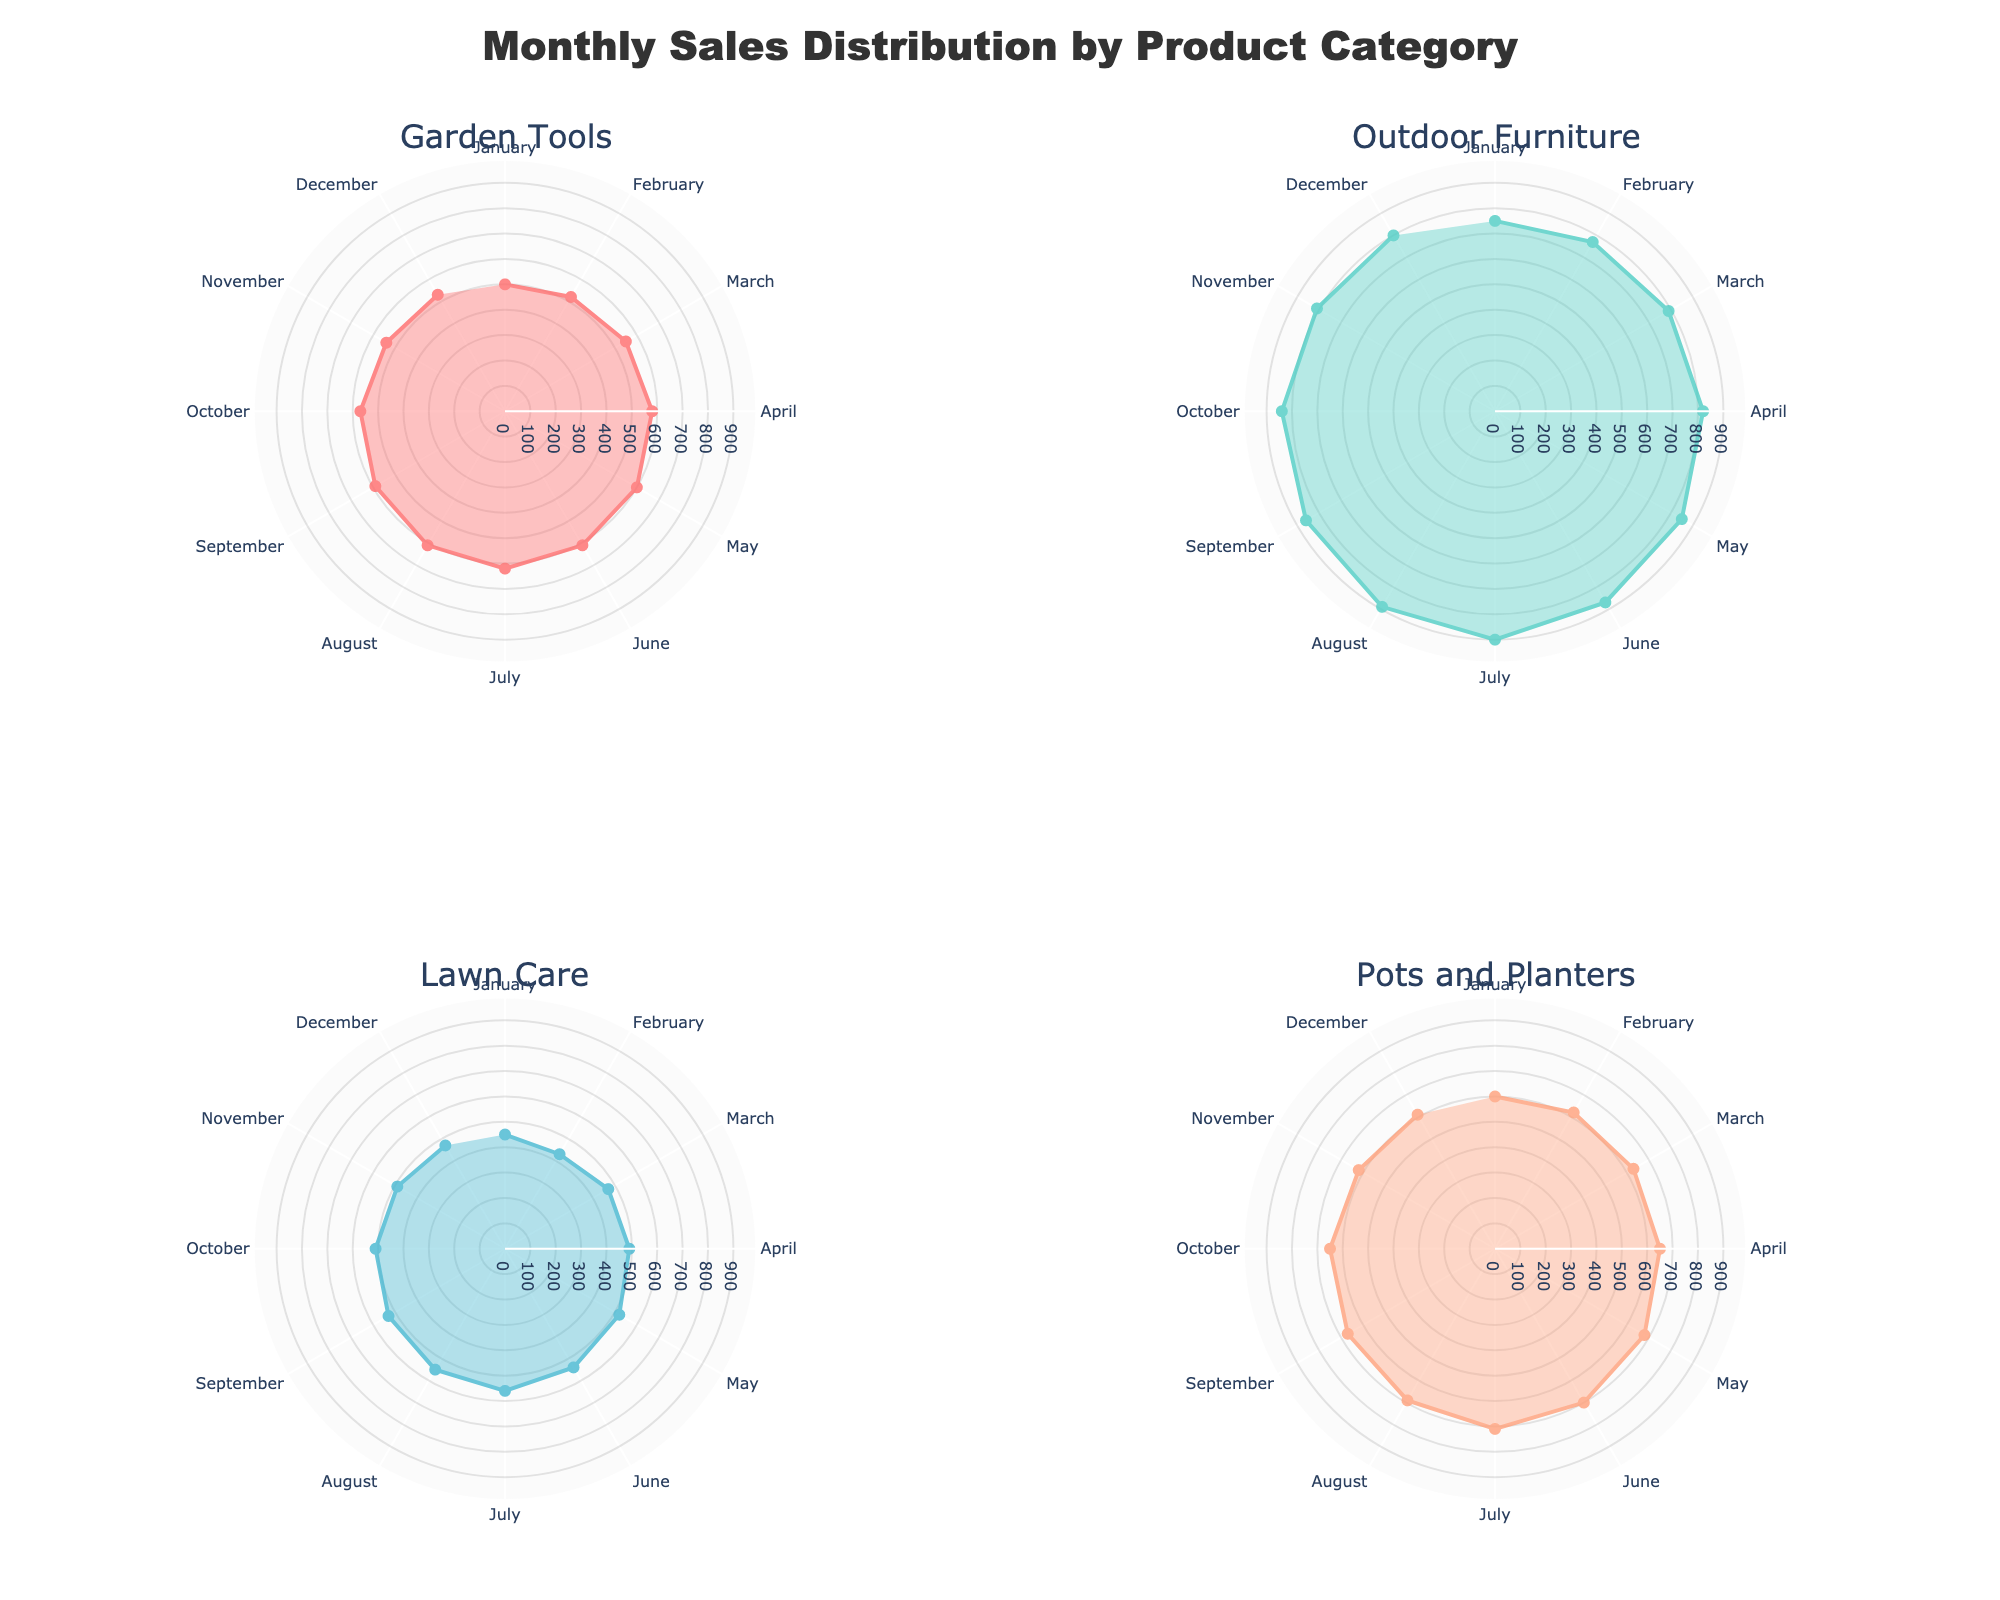How many product categories are displayed in the figure? The figure is divided into four subplots, each representing one product category, which are "Garden Tools," "Outdoor Furniture," "Lawn Care," and "Pots and Planters."
Answer: 4 In which month did "Outdoor Furniture" have its highest sales? By looking at the polar chart for "Outdoor Furniture," you can see that the maximum distance from the center (which represents the maximum sales) occurs in July.
Answer: July Which product category has the most even distribution of sales throughout the year? By examining the various polar charts, "Pots and Planters" appears to have a relatively even sales distribution across all months, as indicated by the near uniform shape in its corresponding subplot.
Answer: Pots and Planters Was there any product category where sales in December were exactly the same as those in January? If so, which one? By comparing the December and January sales values (the radial distances from the center) in all four subplots, we notice that for "Pots and Planters," sales in December (610) are equal to sales in January (600).
Answer: Pots and Planters Which product category shows a clear peak in sales during the summer months (June, July, August)? Observing the subplots, "Outdoor Furniture" shows a noticeable peak during the summer months, evidenced by the larger distances from the center in those months.
Answer: Outdoor Furniture What is the total sales difference between July and December for "Garden Tools"? The sales for "Garden Tools" in July are 620, and in December, they are 530. The difference is calculated as 620 - 530 = 90.
Answer: 90 Did "Lawn Care" products ever achieve higher sales than "Outdoor Furniture" in any month? Comparing the radial distances month-by-month in their respective subplots, "Outdoor Furniture" consistently has higher sales than "Lawn Care" in every month.
Answer: No Which month had the lowest sales for "Lawn Care"? By examining the radial distances from the center for "Lawn Care," the smallest distance is found in February, indicating the lowest sales.
Answer: February What is the average sales for "Garden Tools" over the year? To find the average, sum the monthly sales for "Garden Tools" (500 + 520 + 550 + 580 + 600 + 610 + 620 + 610 + 590 + 570 + 540 + 530 = 7220) and divide by 12. The result is 7220 / 12 = 601.67.
Answer: 601.67 